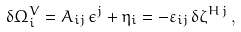<formula> <loc_0><loc_0><loc_500><loc_500>\delta \Omega _ { i } ^ { V } = A _ { i j } \, \epsilon ^ { j } + \eta _ { i } = - \varepsilon _ { i j } \, \delta \zeta ^ { H \, j } \, ,</formula> 